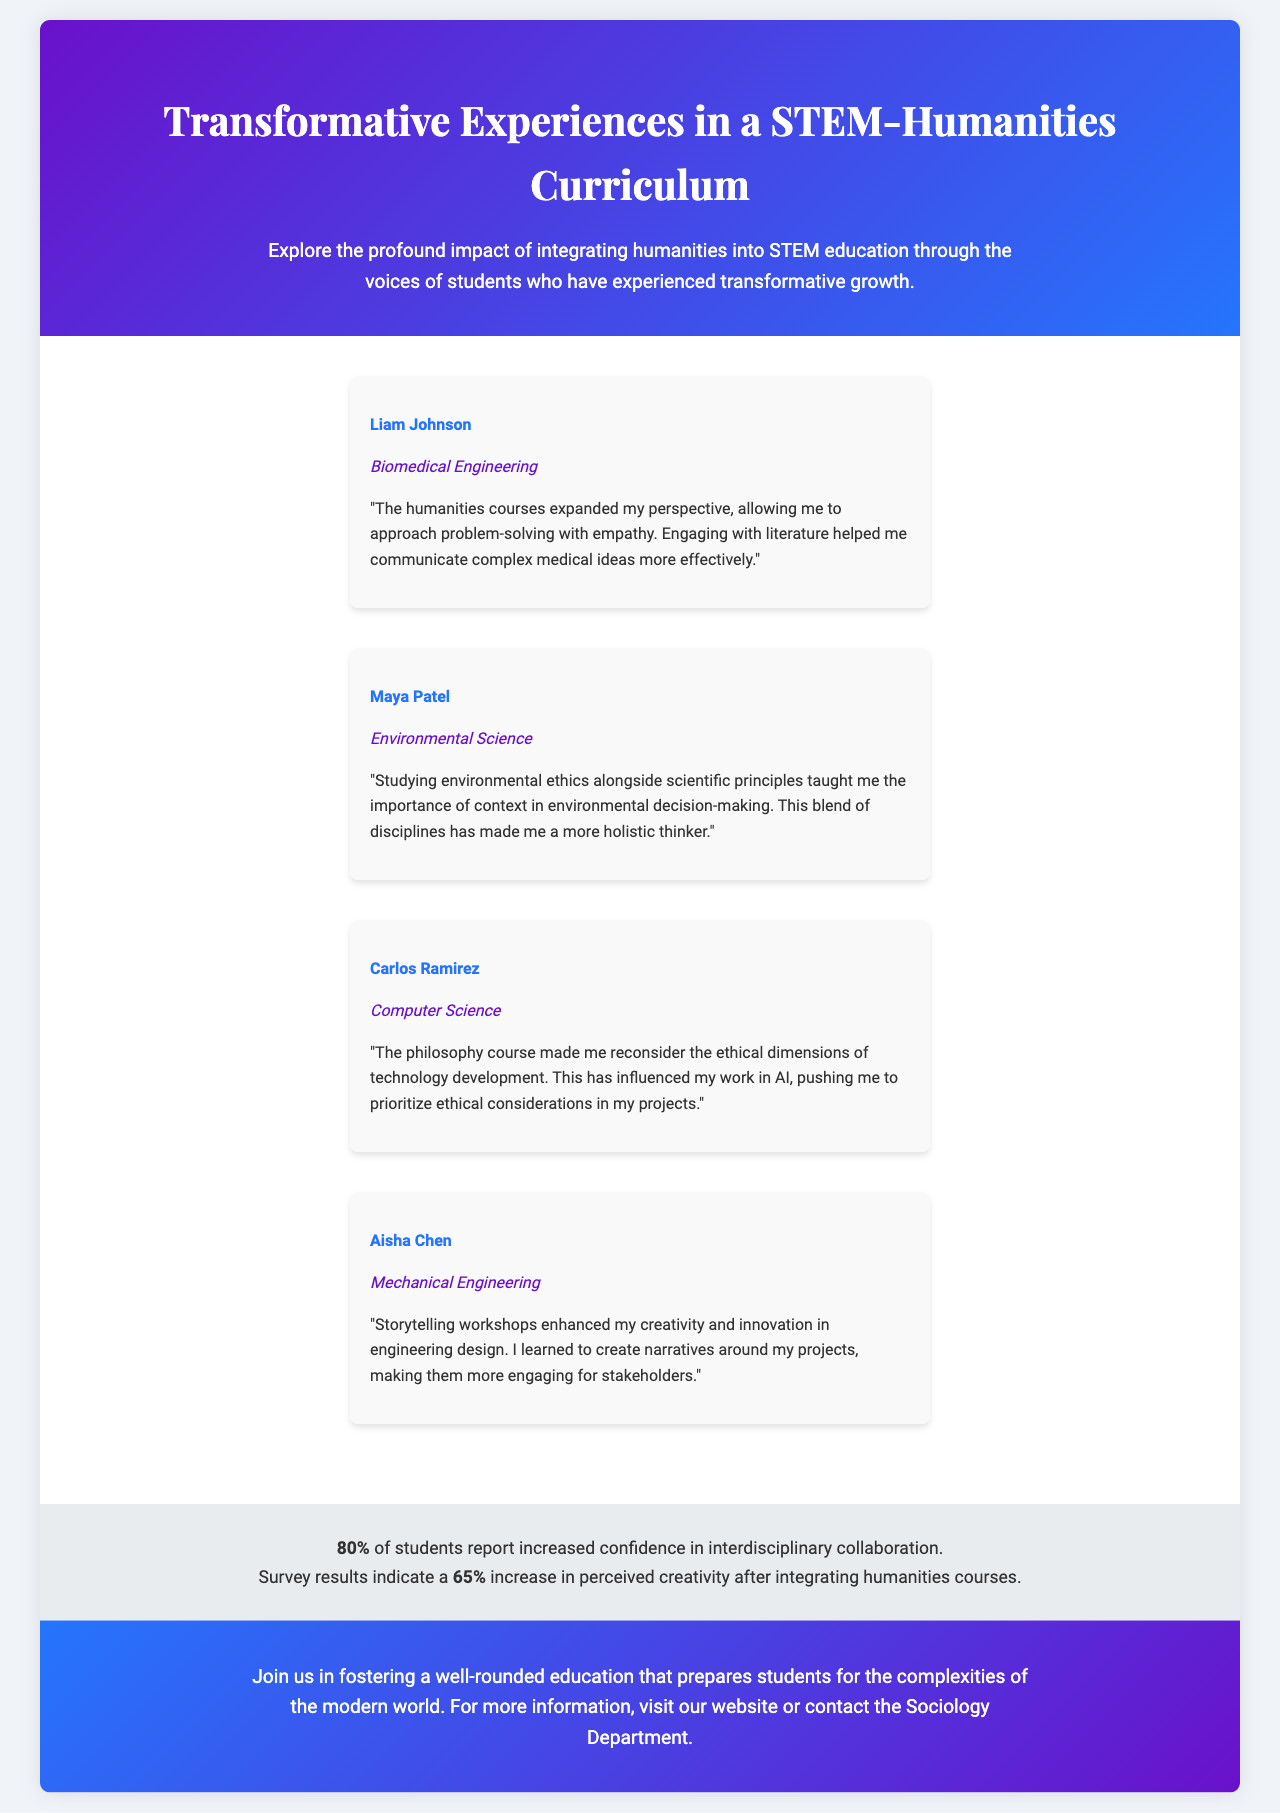what is the name of a student who studied Biomedical Engineering? The document lists several student testimonials, one of which is from Liam Johnson, who is studying Biomedical Engineering.
Answer: Liam Johnson how many students reported increased confidence in interdisciplinary collaboration? According to the document, 80% of students reported increased confidence in interdisciplinary collaboration.
Answer: 80% what impact percentage indicates an increase in perceived creativity after incorporating humanities? The document states that there is a 65% increase in perceived creativity after integrating humanities courses.
Answer: 65% which student emphasized the importance of storytelling in their engineering design? Aisha Chen highlighted how storytelling workshops enhanced her creativity and innovation in engineering design.
Answer: Aisha Chen what is the main theme of the testimonials presented in the document? The testimonials collectively focus on the impact of integrating humanities into STEM education on students' perspectives and skills.
Answer: Impact of integrating humanities in STEM education which degree program does Maya Patel belong to? The document identifies Maya Patel as a student in the Environmental Science program.
Answer: Environmental Science what is the purpose of the call-to-action section in the brochure? The call-to-action encourages readers to join in fostering a well-rounded education that prepares students for modern complexities.
Answer: Foster a well-rounded education which student mentioned the ethical dimensions of technology development? Carlos Ramirez mentioned rethinking the ethical dimensions of technology development through a philosophy course.
Answer: Carlos Ramirez 